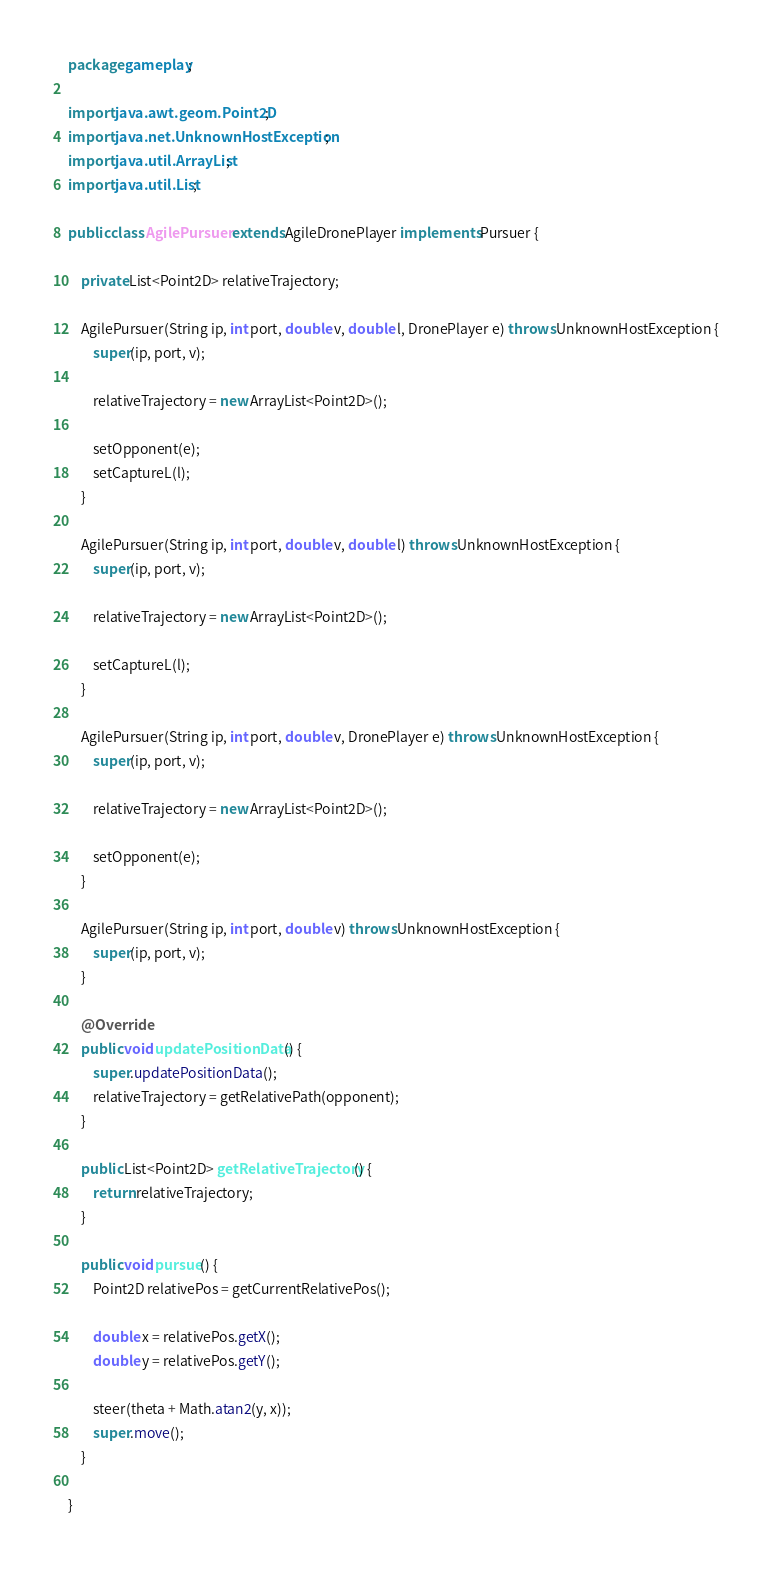<code> <loc_0><loc_0><loc_500><loc_500><_Java_>package gameplay;

import java.awt.geom.Point2D;
import java.net.UnknownHostException;
import java.util.ArrayList;
import java.util.List;

public class AgilePursuer extends AgileDronePlayer implements Pursuer {
	
	private List<Point2D> relativeTrajectory;
	
	AgilePursuer(String ip, int port, double v, double l, DronePlayer e) throws UnknownHostException {
		super(ip, port, v);
		
		relativeTrajectory = new ArrayList<Point2D>();
		
		setOpponent(e);
		setCaptureL(l);
	}
	
	AgilePursuer(String ip, int port, double v, double l) throws UnknownHostException {
		super(ip, port, v);
		
		relativeTrajectory = new ArrayList<Point2D>();
		
		setCaptureL(l);	
	}
	
	AgilePursuer(String ip, int port, double v, DronePlayer e) throws UnknownHostException {
		super(ip, port, v);
		
		relativeTrajectory = new ArrayList<Point2D>();
		
		setOpponent(e);
	}
	
	AgilePursuer(String ip, int port, double v) throws UnknownHostException {
		super(ip, port, v);
	}
	
	@Override
	public void updatePositionData() {
		super.updatePositionData();
		relativeTrajectory = getRelativePath(opponent);
	}
	
	public List<Point2D> getRelativeTrajectory() {
		return relativeTrajectory;
	}
	
	public void pursue() {		
		Point2D relativePos = getCurrentRelativePos();
		
		double x = relativePos.getX();
		double y = relativePos.getY();
		
		steer(theta + Math.atan2(y, x));
		super.move();
	}

}
</code> 